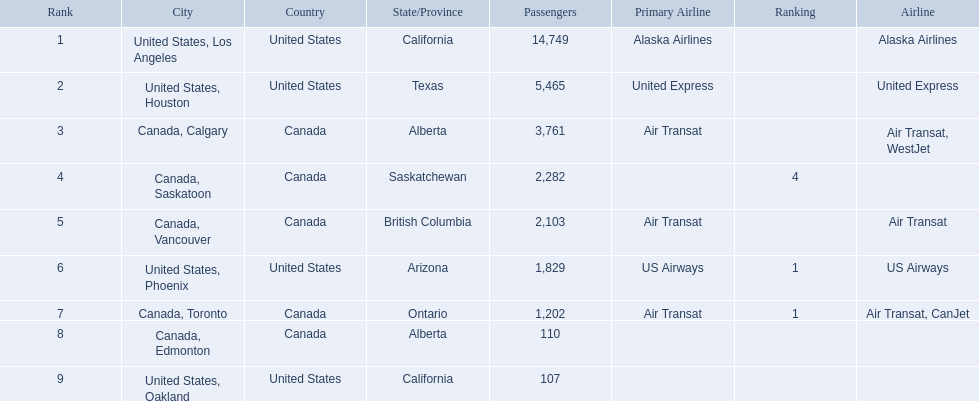What numbers are in the passengers column? 14,749, 5,465, 3,761, 2,282, 2,103, 1,829, 1,202, 110, 107. Which number is the lowest number in the passengers column? 107. What city is associated with this number? United States, Oakland. 